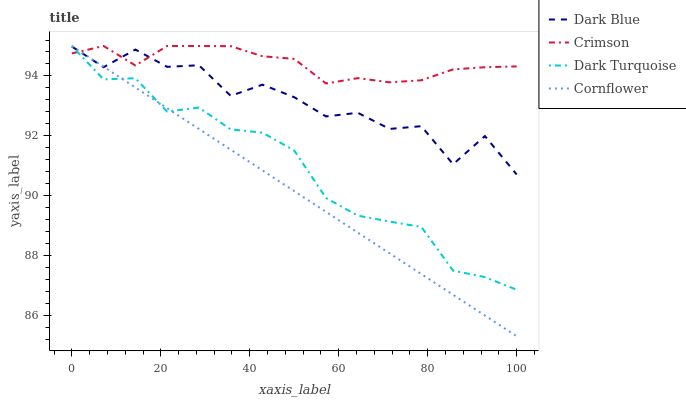Does Cornflower have the minimum area under the curve?
Answer yes or no. Yes. Does Crimson have the maximum area under the curve?
Answer yes or no. Yes. Does Dark Blue have the minimum area under the curve?
Answer yes or no. No. Does Dark Blue have the maximum area under the curve?
Answer yes or no. No. Is Cornflower the smoothest?
Answer yes or no. Yes. Is Dark Blue the roughest?
Answer yes or no. Yes. Is Dark Blue the smoothest?
Answer yes or no. No. Is Cornflower the roughest?
Answer yes or no. No. Does Dark Blue have the lowest value?
Answer yes or no. No. Does Dark Turquoise have the highest value?
Answer yes or no. Yes. Does Dark Blue have the highest value?
Answer yes or no. No. Does Dark Blue intersect Cornflower?
Answer yes or no. Yes. Is Dark Blue less than Cornflower?
Answer yes or no. No. Is Dark Blue greater than Cornflower?
Answer yes or no. No. 